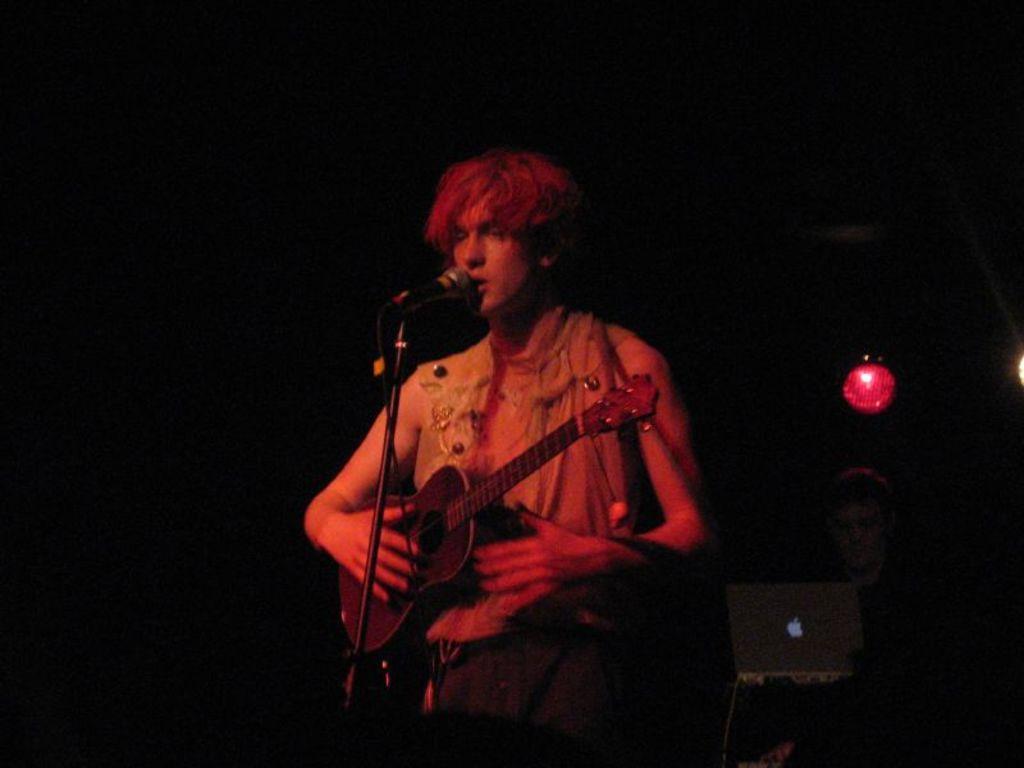Could you give a brief overview of what you see in this image? In this image I can see man is playing guitar in front of a microphone. 